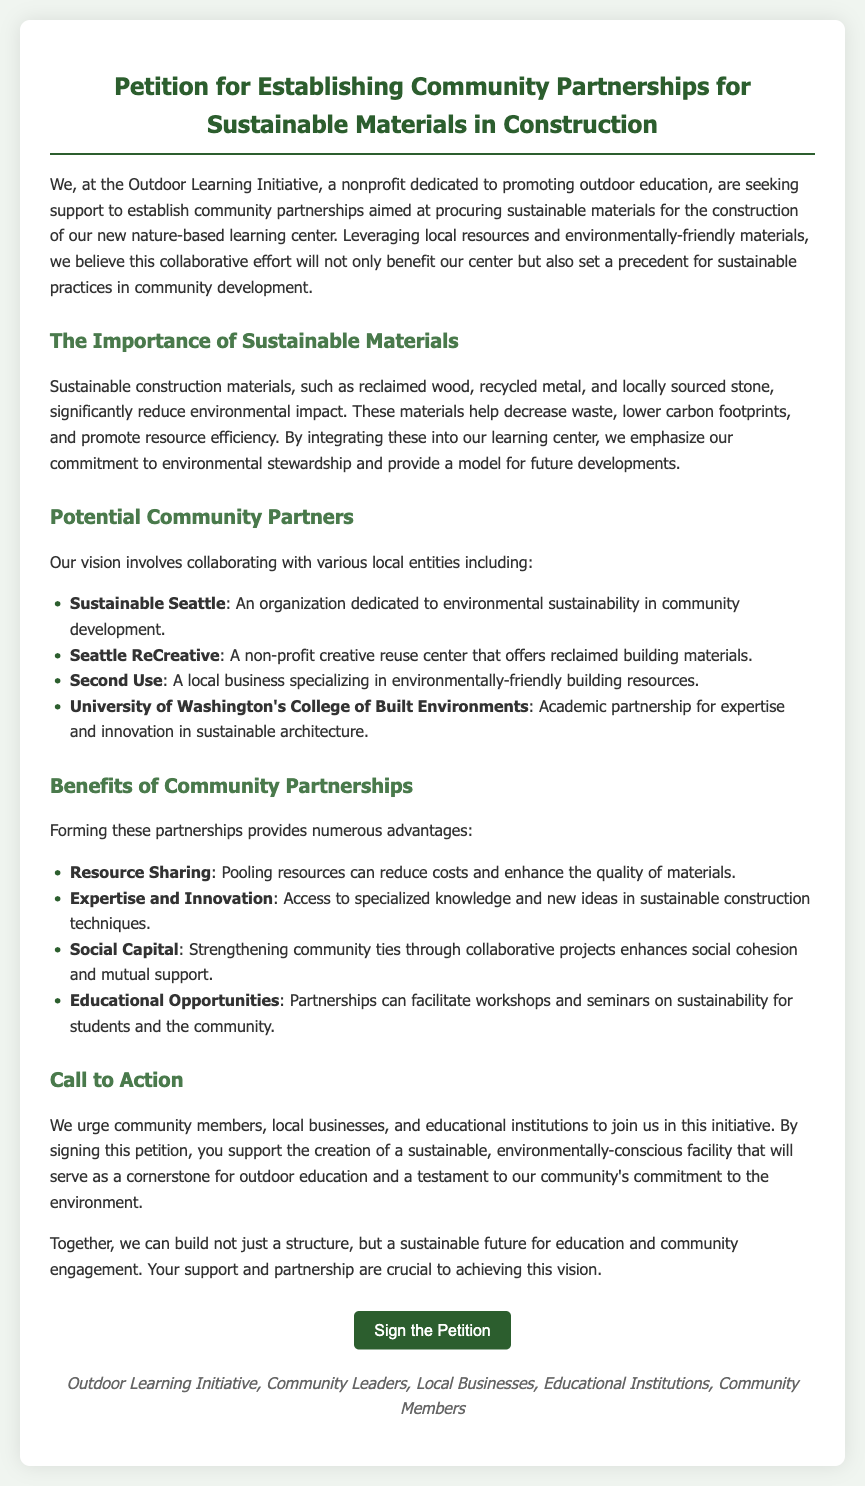What is the title of the petition? The title of the petition is clearly stated at the top of the document, emphasizing its purpose.
Answer: Petition for Establishing Community Partnerships for Sustainable Materials in Construction Who is the nonprofit organization mentioned? The document explicitly names the nonprofit organization that is seeking support for the petition.
Answer: Outdoor Learning Initiative What materials are highlighted as sustainable in the petition? The petition lists specific sustainable materials that are intended for construction within the center.
Answer: Reclaimed wood, recycled metal, locally sourced stone Which local entity focuses on environmental sustainability? The document provides names of potential partners, indicating which organization focuses on sustainability.
Answer: Sustainable Seattle What is one benefit of forming community partnerships? The document mentions several advantages of forming these partnerships, highlighting one key benefit.
Answer: Resource Sharing How many local businesses are mentioned as potential partners? The document includes a list of local businesses that could partner for sustainable construction materials, allowing for a numerical answer.
Answer: Two What is the main call to action in the petition? The document outlines the primary action the petitioners are urging community members to take.
Answer: Sign the Petition What color is used for the header of the petition? The document describes the design theme, including the color used for the petition's header.
Answer: Green 